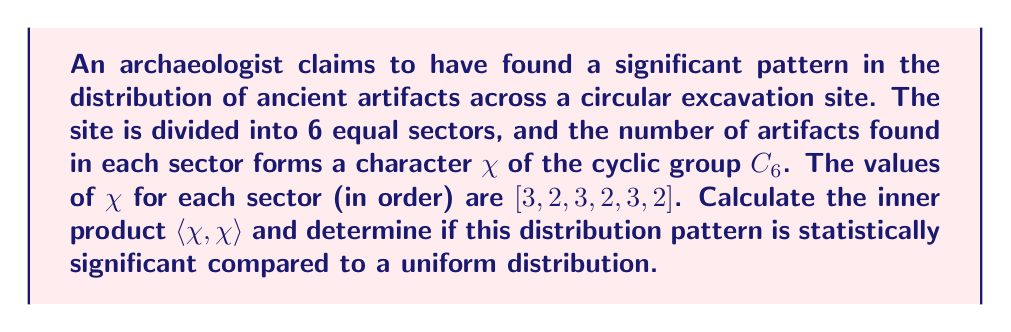What is the answer to this math problem? To analyze the statistical significance of the artifact distribution pattern using character theory, we'll follow these steps:

1) First, recall that for a character $\chi$ of a finite group $G$, the inner product is defined as:

   $$\langle \chi, \chi \rangle = \frac{1}{|G|} \sum_{g \in G} |\chi(g)|^2$$

2) In this case, $G = C_6$, so $|G| = 6$.

3) The character values are $[3, 2, 3, 2, 3, 2]$. We need to square each of these values:

   $$[3^2, 2^2, 3^2, 2^2, 3^2, 2^2] = [9, 4, 9, 4, 9, 4]$$

4) Now, we sum these squared values:

   $$9 + 4 + 9 + 4 + 9 + 4 = 39$$

5) Finally, we divide by $|G| = 6$:

   $$\langle \chi, \chi \rangle = \frac{1}{6} \cdot 39 = \frac{13}{2} = 6.5$$

6) To determine if this is statistically significant, we compare it to the inner product of a uniform distribution. A uniform distribution would have the same number of artifacts in each sector, let's say 1. The character for a uniform distribution would be $[1, 1, 1, 1, 1, 1]$.

7) The inner product of the uniform distribution with itself would be:

   $$\langle \chi_{uniform}, \chi_{uniform} \rangle = \frac{1}{6}(1^2 + 1^2 + 1^2 + 1^2 + 1^2 + 1^2) = 1$$

8) The observed inner product (6.5) is significantly larger than the uniform distribution's inner product (1), indicating that the observed distribution is statistically significant and deviates from uniformity.
Answer: $\langle \chi, \chi \rangle = 6.5$; statistically significant. 